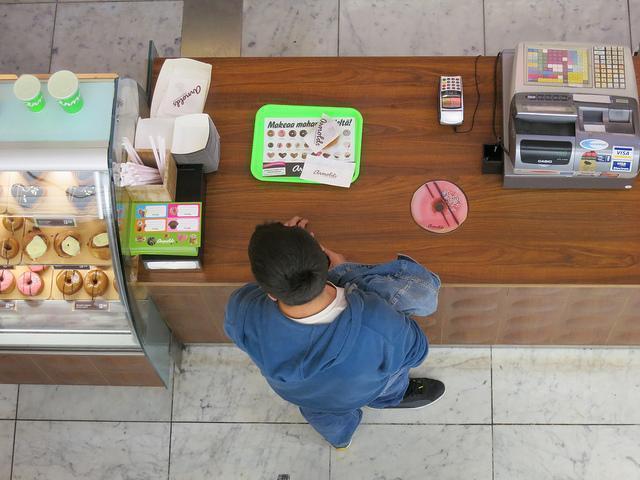Who is the man waiting for?
Choose the right answer and clarify with the format: 'Answer: answer
Rationale: rationale.'
Options: Mechanic, cashier, doctor, banker. Answer: cashier.
Rationale: The man is waiting patiently for the cashier to return so he can buy some doughnuts. she had to run into the back for a moment, but will return in two minutes!. 